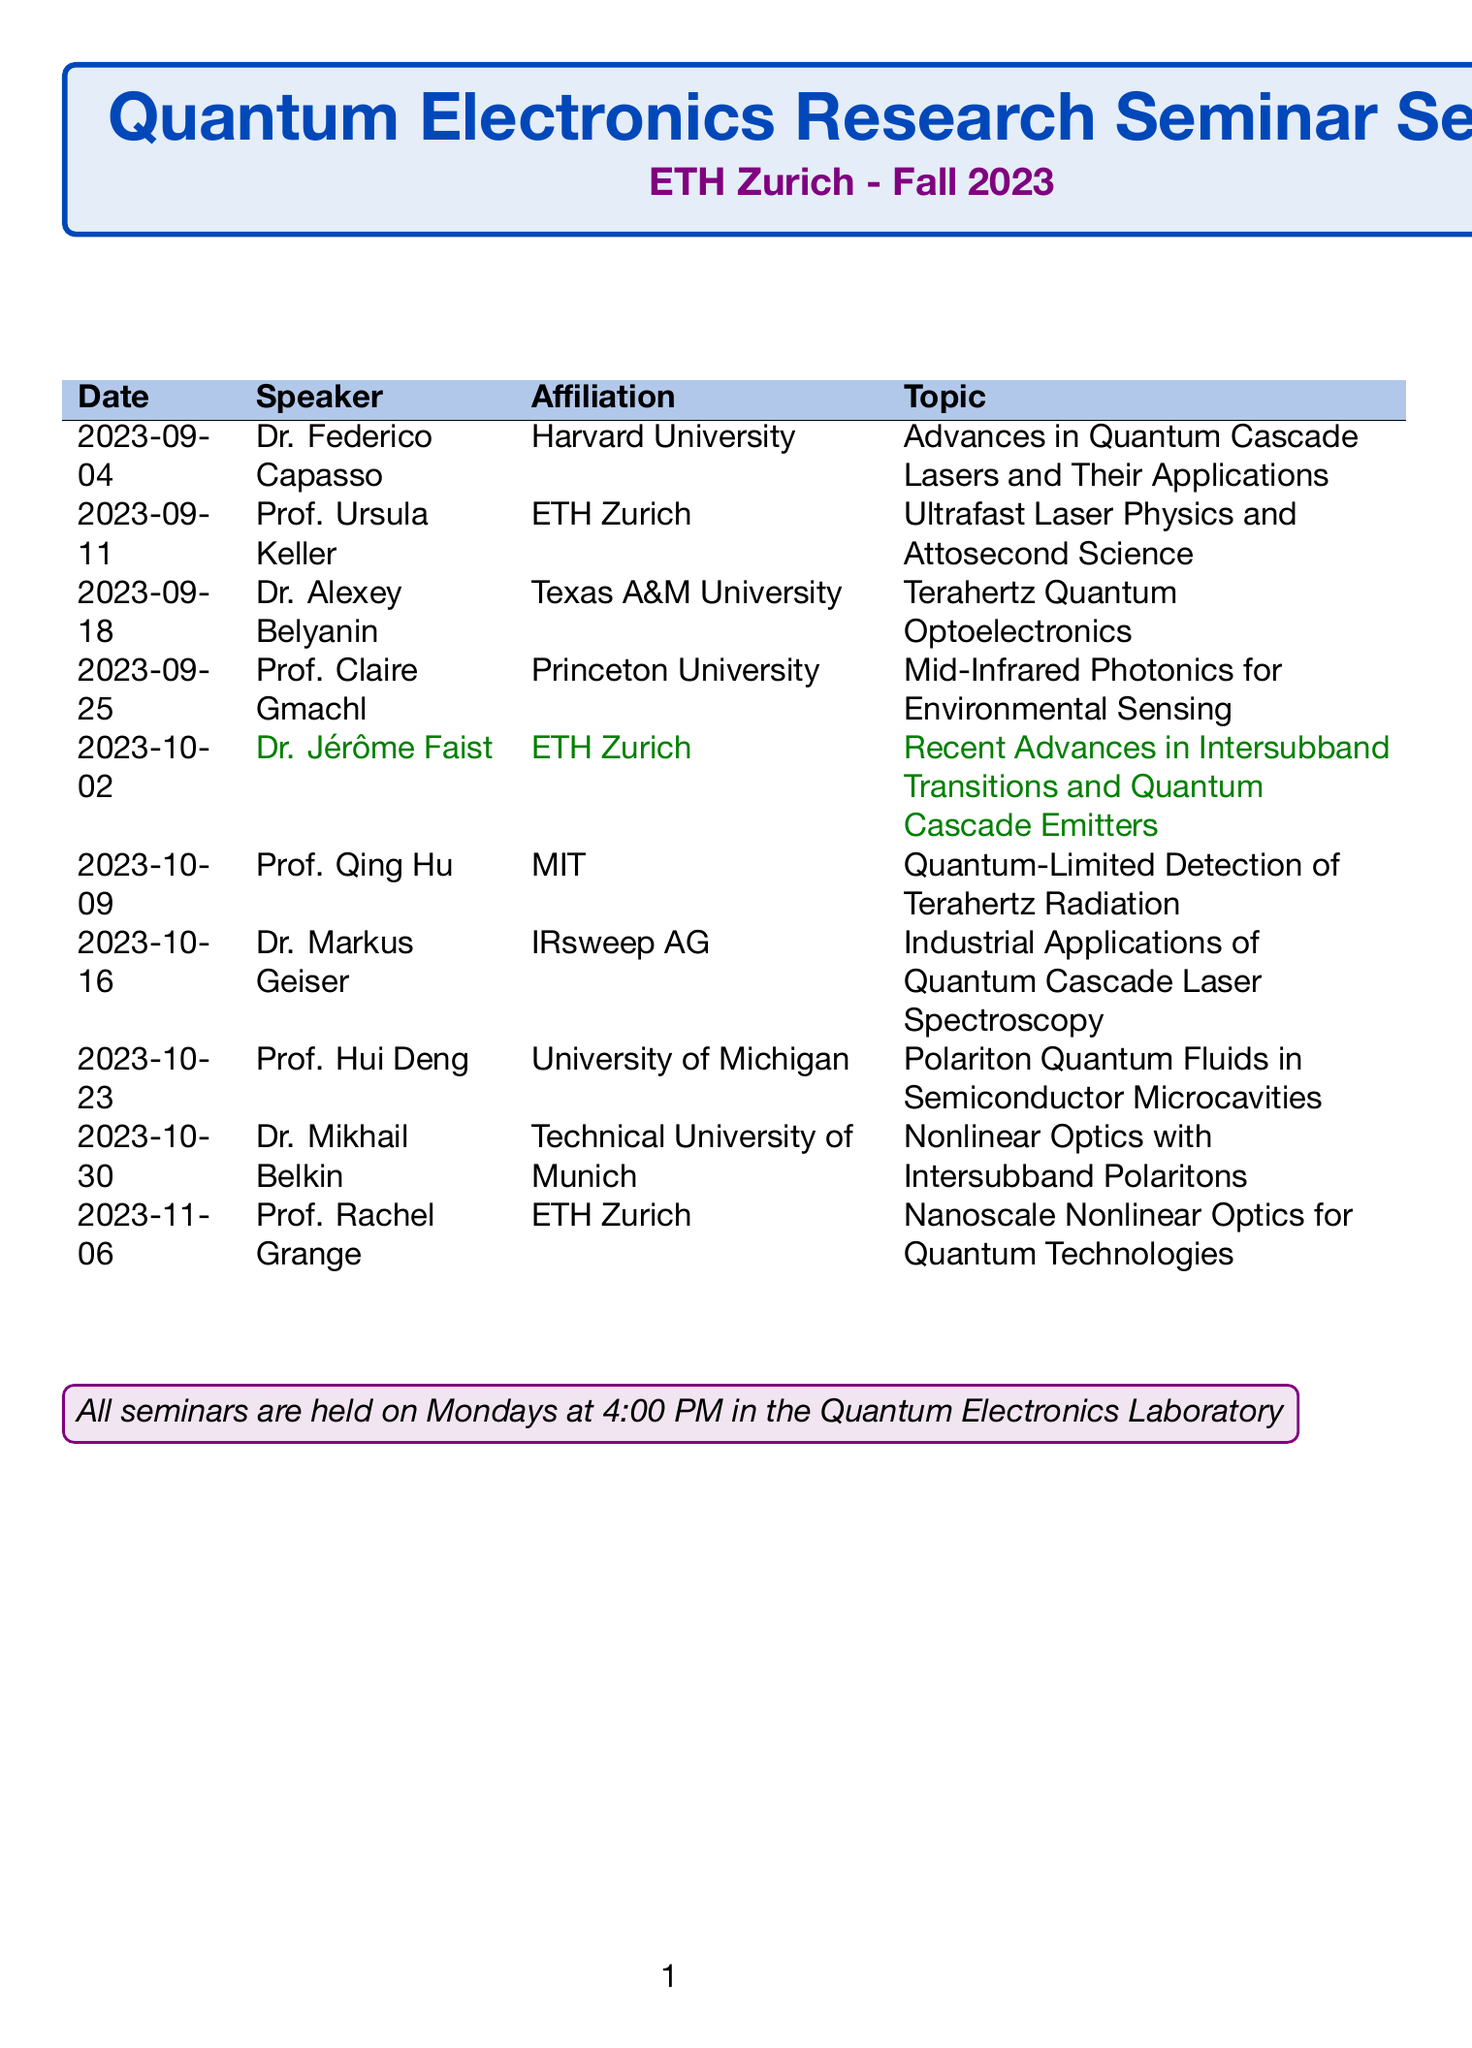What is the title of the seminar series? The title of the seminar series is presented at the beginning of the document.
Answer: Quantum Electronics Research Seminar Series Who is the speaker for week 5? The speaker is listed in the weekly schedule for week 5.
Answer: Dr. Jérôme Faist What date does the first seminar take place? The date of the first seminar is mentioned in the schedule.
Answer: 2023-09-04 Which institution is Dr. Federico Capasso affiliated with? The affiliation of Dr. Federico Capasso is provided in the schedule for his seminar.
Answer: Harvard University What topic will Prof. Ursula Keller discuss? The topic for Prof. Ursula Keller's seminar is specified in the document.
Answer: Ultrafast Laser Physics and Attosecond Science How many seminars are scheduled for October? The total number of seminars in October can be calculated by counting the listed weeks in the document.
Answer: 5 What is the time for the seminars? The time for the seminars is stated in the special note at the bottom of the document.
Answer: 4:00 PM Which speaker is affiliated with ETH Zurich? The list shows several speakers; this person is specifically mentioned for their week.
Answer: Dr. Jérôme Faist What is the topic for the last seminar? The topic for the last seminar is indicated in the schedule.
Answer: Nanoscale Nonlinear Optics for Quantum Technologies 